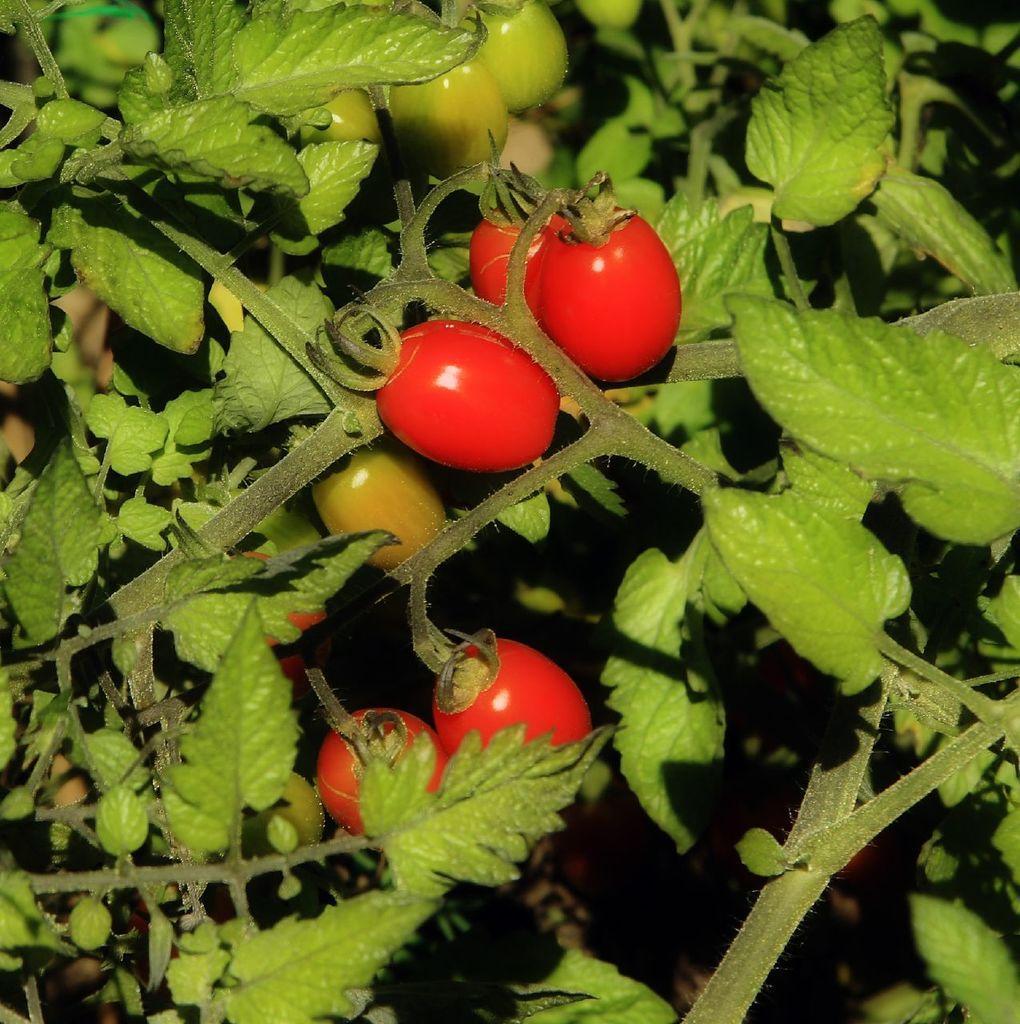Could you give a brief overview of what you see in this image? In this picture there are tomato plants and tomatoes. 